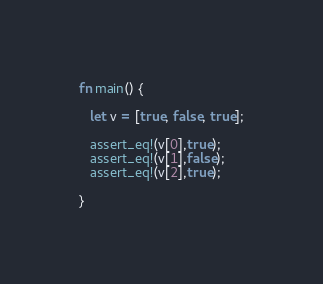<code> <loc_0><loc_0><loc_500><loc_500><_Rust_>
fn main() {

   let v = [true, false, true];

   assert_eq!(v[0],true);
   assert_eq!(v[1],false);
   assert_eq!(v[2],true);

}</code> 